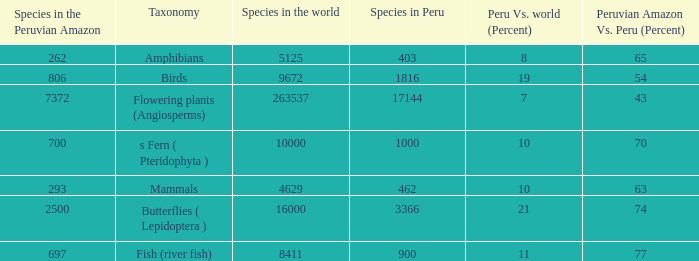Can you parse all the data within this table? {'header': ['Species in the Peruvian Amazon', 'Taxonomy', 'Species in the world', 'Species in Peru', 'Peru Vs. world (Percent)', 'Peruvian Amazon Vs. Peru (Percent)'], 'rows': [['262', 'Amphibians', '5125', '403', '8', '65'], ['806', 'Birds', '9672', '1816', '19', '54'], ['7372', 'Flowering plants (Angiosperms)', '263537', '17144', '7', '43'], ['700', 's Fern ( Pteridophyta )', '10000', '1000', '10', '70'], ['293', 'Mammals', '4629', '462', '10', '63'], ['2500', 'Butterflies ( Lepidoptera )', '16000', '3366', '21', '74'], ['697', 'Fish (river fish)', '8411', '900', '11', '77']]} What's the minimum species in the peruvian amazon with taxonomy s fern ( pteridophyta ) 700.0. 